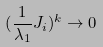Convert formula to latex. <formula><loc_0><loc_0><loc_500><loc_500>( \frac { 1 } { \lambda _ { 1 } } J _ { i } ) ^ { k } \rightarrow 0</formula> 